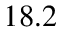Convert formula to latex. <formula><loc_0><loc_0><loc_500><loc_500>1 8 . 2</formula> 